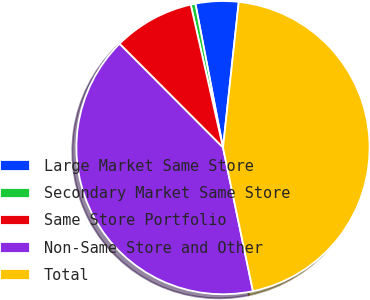<chart> <loc_0><loc_0><loc_500><loc_500><pie_chart><fcel>Large Market Same Store<fcel>Secondary Market Same Store<fcel>Same Store Portfolio<fcel>Non-Same Store and Other<fcel>Total<nl><fcel>4.73%<fcel>0.52%<fcel>8.94%<fcel>40.8%<fcel>45.01%<nl></chart> 